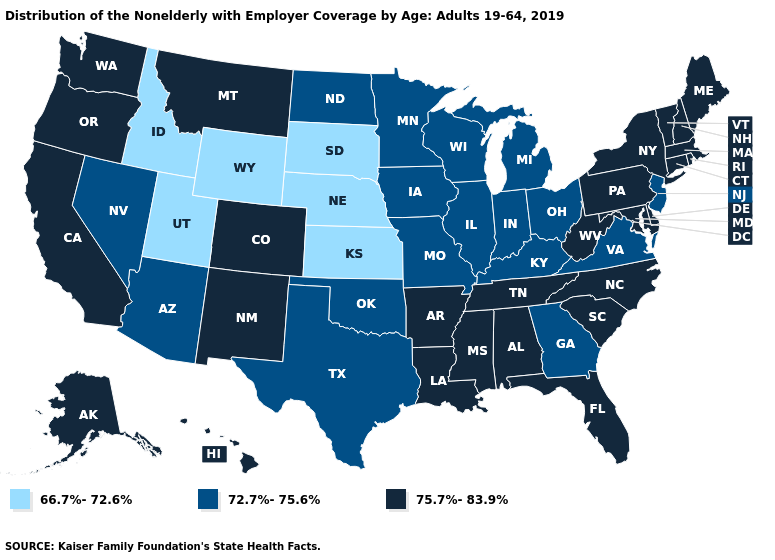Does South Dakota have the lowest value in the USA?
Keep it brief. Yes. What is the value of Washington?
Short answer required. 75.7%-83.9%. What is the highest value in states that border Idaho?
Answer briefly. 75.7%-83.9%. What is the value of North Dakota?
Give a very brief answer. 72.7%-75.6%. Name the states that have a value in the range 72.7%-75.6%?
Short answer required. Arizona, Georgia, Illinois, Indiana, Iowa, Kentucky, Michigan, Minnesota, Missouri, Nevada, New Jersey, North Dakota, Ohio, Oklahoma, Texas, Virginia, Wisconsin. Which states have the lowest value in the MidWest?
Write a very short answer. Kansas, Nebraska, South Dakota. What is the highest value in the USA?
Write a very short answer. 75.7%-83.9%. What is the highest value in states that border Florida?
Quick response, please. 75.7%-83.9%. Does Michigan have a lower value than Hawaii?
Concise answer only. Yes. Among the states that border Alabama , which have the highest value?
Quick response, please. Florida, Mississippi, Tennessee. Does Utah have the lowest value in the USA?
Answer briefly. Yes. Which states have the lowest value in the USA?
Keep it brief. Idaho, Kansas, Nebraska, South Dakota, Utah, Wyoming. What is the value of New Jersey?
Quick response, please. 72.7%-75.6%. What is the lowest value in the South?
Short answer required. 72.7%-75.6%. 